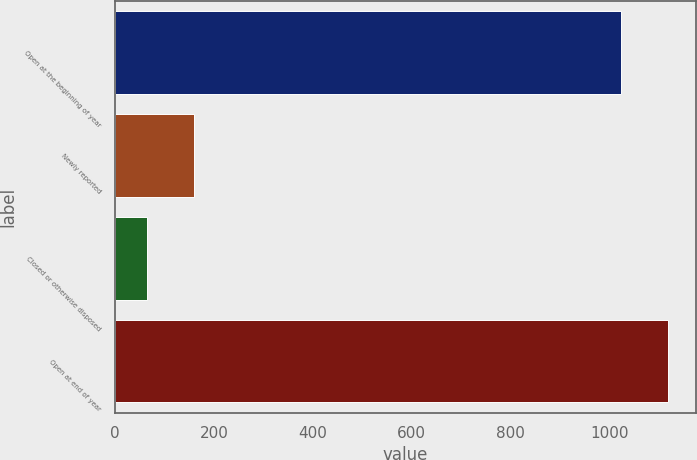Convert chart to OTSL. <chart><loc_0><loc_0><loc_500><loc_500><bar_chart><fcel>Open at the beginning of year<fcel>Newly reported<fcel>Closed or otherwise disposed<fcel>Open at end of year<nl><fcel>1023<fcel>160.1<fcel>64<fcel>1119.1<nl></chart> 